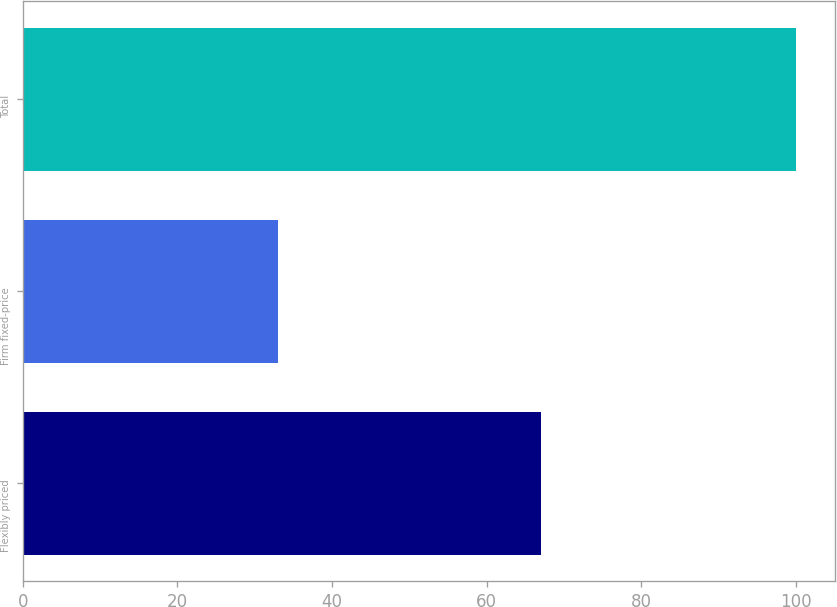<chart> <loc_0><loc_0><loc_500><loc_500><bar_chart><fcel>Flexibly priced<fcel>Firm fixed-price<fcel>Total<nl><fcel>67<fcel>33<fcel>100<nl></chart> 